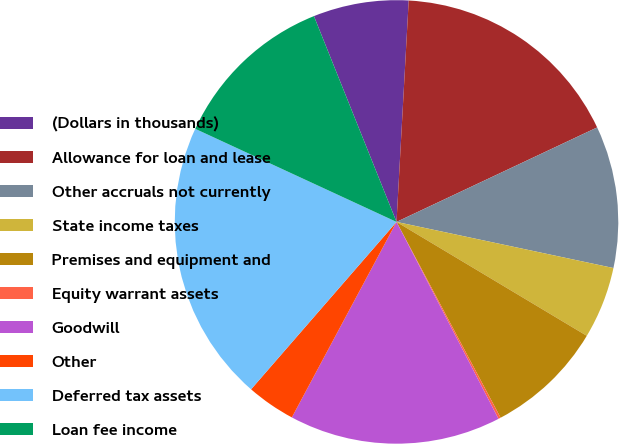<chart> <loc_0><loc_0><loc_500><loc_500><pie_chart><fcel>(Dollars in thousands)<fcel>Allowance for loan and lease<fcel>Other accruals not currently<fcel>State income taxes<fcel>Premises and equipment and<fcel>Equity warrant assets<fcel>Goodwill<fcel>Other<fcel>Deferred tax assets<fcel>Loan fee income<nl><fcel>6.95%<fcel>17.12%<fcel>10.34%<fcel>5.25%<fcel>8.64%<fcel>0.17%<fcel>15.43%<fcel>3.56%<fcel>20.51%<fcel>12.03%<nl></chart> 